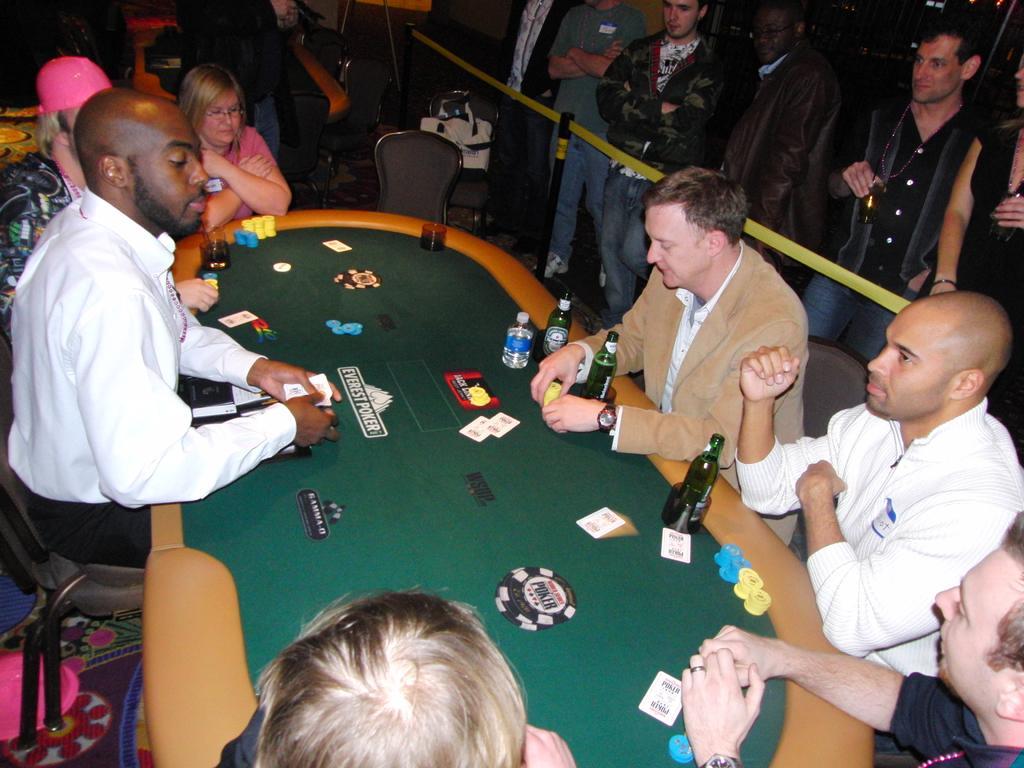Can you describe this image briefly? This picture describes about group of people few are seated on the chair and few are standing, in front of the seated people we can find bottles, cards on the table. 